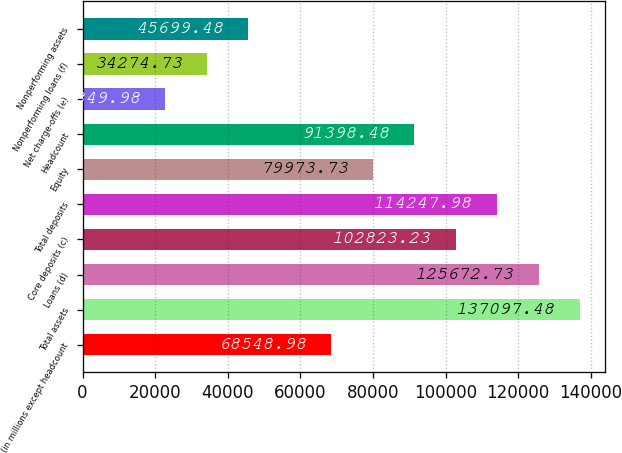Convert chart. <chart><loc_0><loc_0><loc_500><loc_500><bar_chart><fcel>(in millions except headcount<fcel>Total assets<fcel>Loans (d)<fcel>Core deposits (c)<fcel>Total deposits<fcel>Equity<fcel>Headcount<fcel>Net charge-offs (e)<fcel>Nonperforming loans (f)<fcel>Nonperforming assets<nl><fcel>68549<fcel>137097<fcel>125673<fcel>102823<fcel>114248<fcel>79973.7<fcel>91398.5<fcel>22850<fcel>34274.7<fcel>45699.5<nl></chart> 